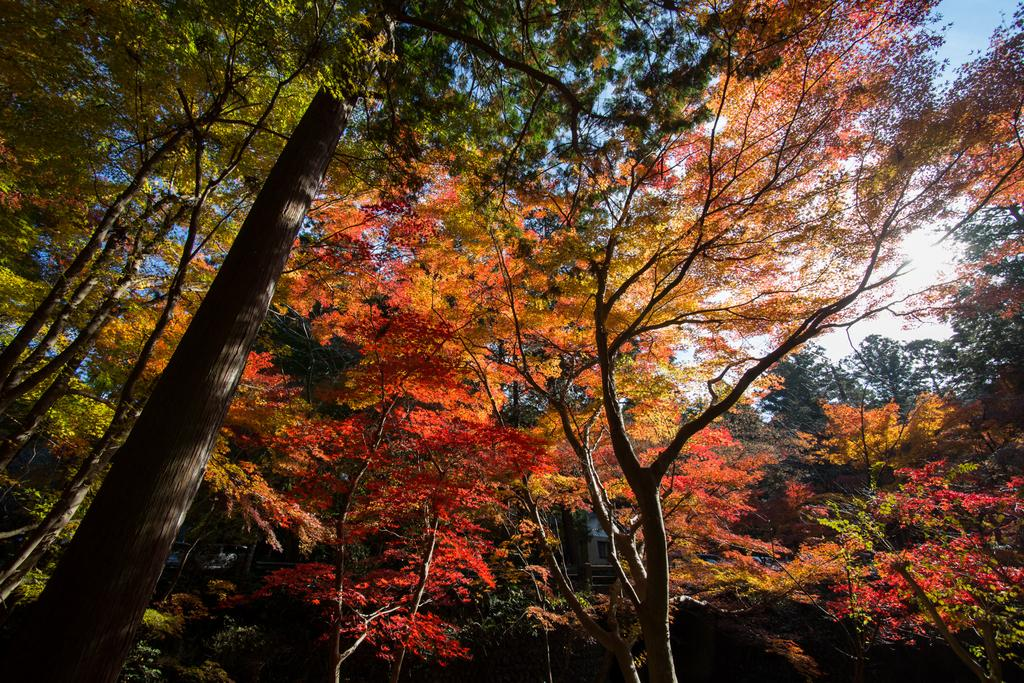What type of vegetation can be seen in the image? There are trees in the image. What colors are the leaves of the trees in the image? Some trees have red leaves, and some trees have yellow leaves. What type of steel structure can be seen in the image? There is no steel structure present in the image; it features trees with red and yellow leaves. What religious symbols are visible in the image? There are no religious symbols present in the image; it features trees with red and yellow leaves. 